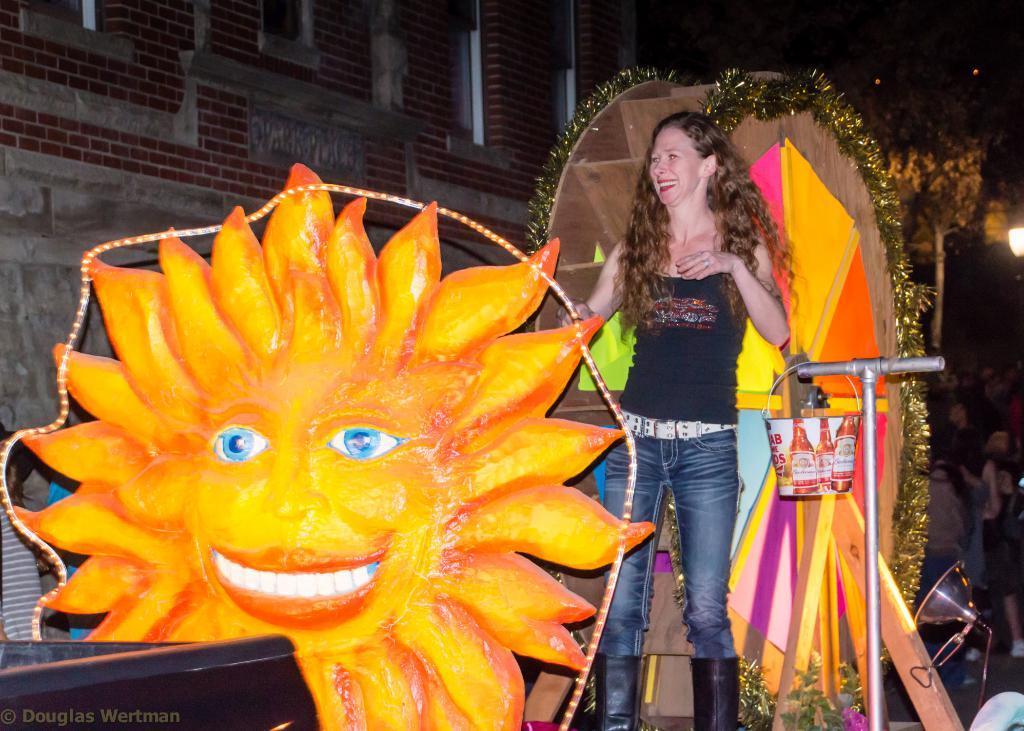How would you summarize this image in a sentence or two? In this image we can see a women wearing black t-shirt and long boots is standing on the surface where few decorative items are placed. Here we can see a pole where a bucket is hanged also we can see the lights. In the background, we can see a brick wall, trees, few people standing here and lights. 